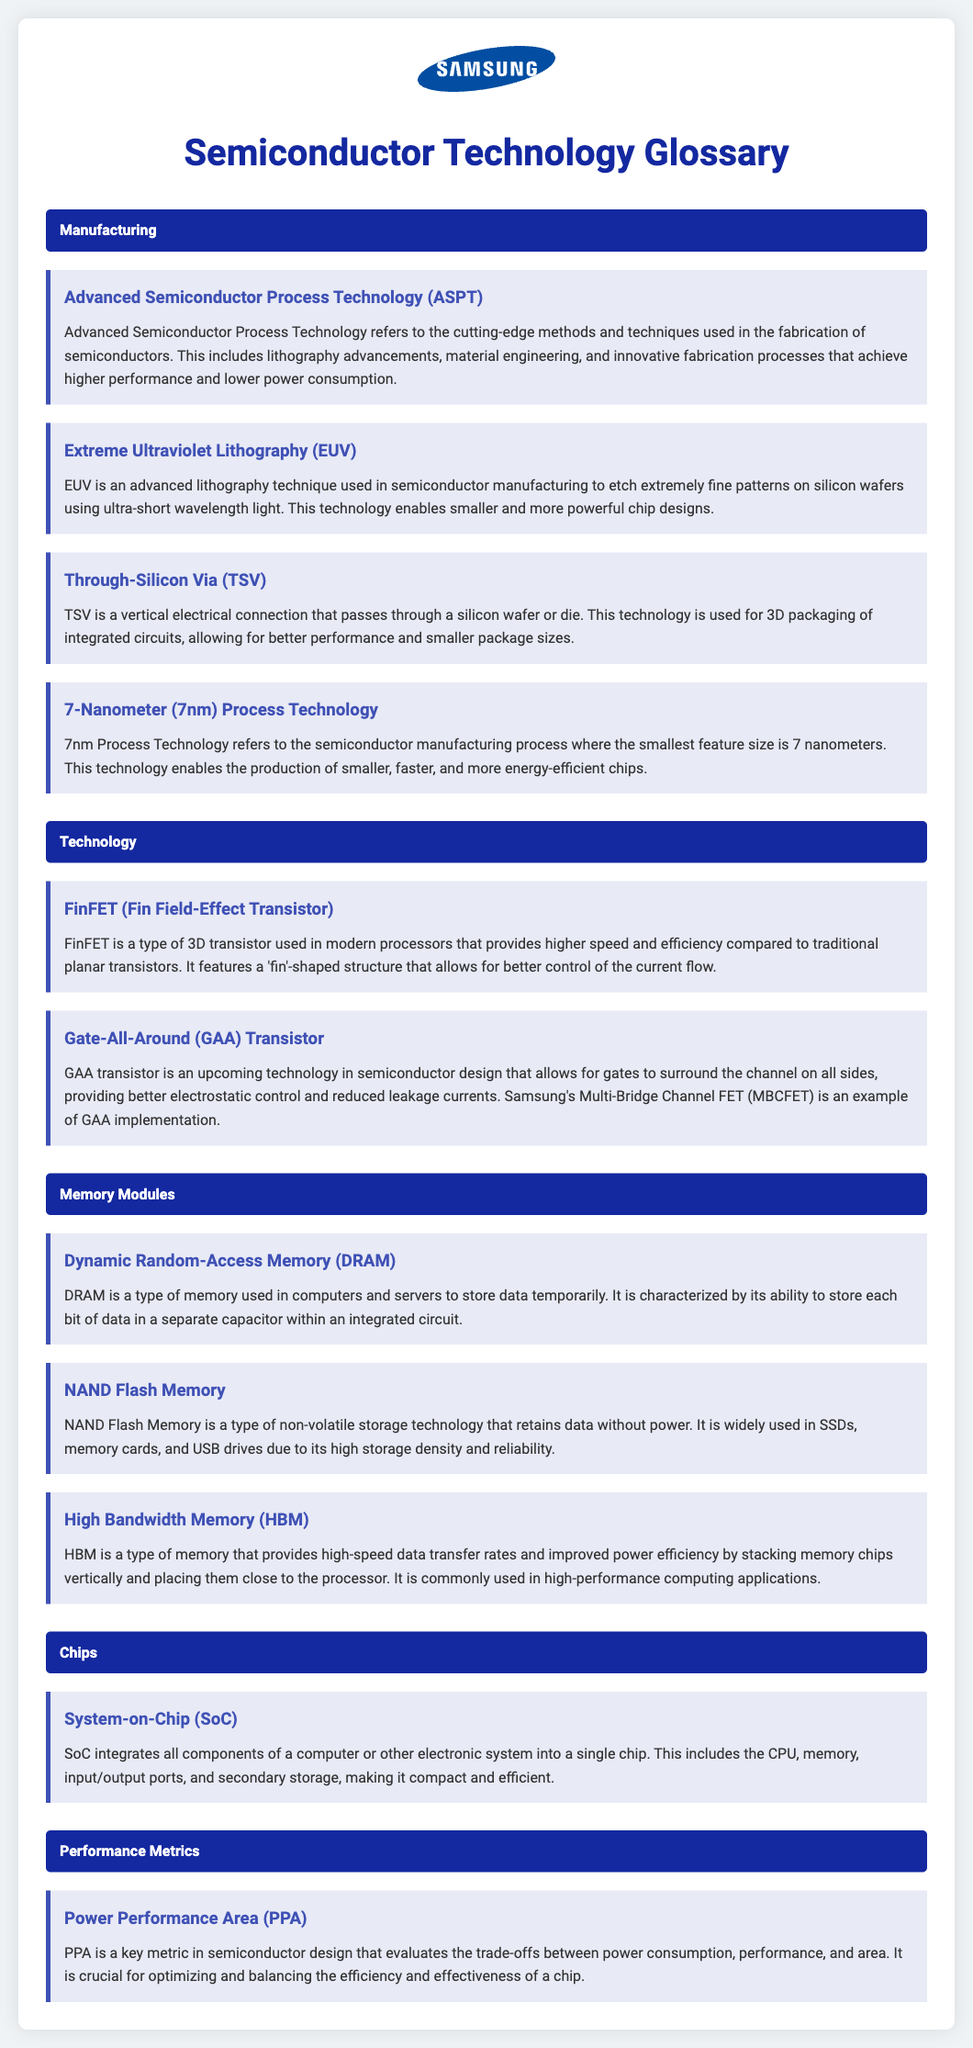What does ASPT stand for? The document defines ASPT as Advanced Semiconductor Process Technology used in semiconductor fabrication.
Answer: Advanced Semiconductor Process Technology What is the smallest feature size used in 7nm Process Technology? The term indicates that the smallest feature size in this technology is 7 nanometers.
Answer: 7 nanometers What does TSV enable in integrated circuits? According to the document, TSV allows for better performance and smaller package sizes in 3D packaging of integrated circuits.
Answer: Better performance and smaller package sizes What type of memory is characterized by separate capacitors in an integrated circuit? The document states that DRAM is characterized by storing each bit of data in a separate capacitor.
Answer: DRAM What is the main benefit of using FinFET transistors? The document says that FinFET provides higher speed and efficiency compared to traditional planar transistors.
Answer: Higher speed and efficiency What technology is known for surrounding the channel on all sides? The document describes Gate-All-Around transistors as allowing gates to surround the channel on all sides.
Answer: Gate-All-Around What does PPA stand for in semiconductor design? The document specifies that PPA stands for Power Performance Area.
Answer: Power Performance Area What type of memory is commonly used in high-performance computing? According to the document, High Bandwidth Memory (HBM) is commonly used in high-performance computing applications.
Answer: High Bandwidth Memory (HBM) What is the purpose of NAND Flash Memory? The document mentions that NAND Flash Memory retains data without power, and it is used for non-volatile storage.
Answer: Retains data without power 